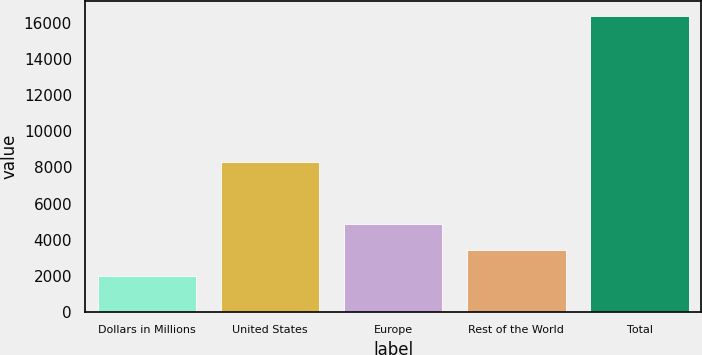Convert chart. <chart><loc_0><loc_0><loc_500><loc_500><bar_chart><fcel>Dollars in Millions<fcel>United States<fcel>Europe<fcel>Rest of the World<fcel>Total<nl><fcel>2013<fcel>8318<fcel>4887.4<fcel>3450.2<fcel>16385<nl></chart> 